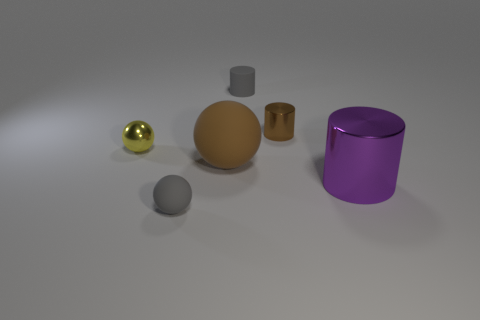Add 1 large brown cylinders. How many objects exist? 7 Add 2 tiny brown matte cylinders. How many tiny brown matte cylinders exist? 2 Subtract 0 green spheres. How many objects are left? 6 Subtract all yellow shiny things. Subtract all blue rubber things. How many objects are left? 5 Add 2 small things. How many small things are left? 6 